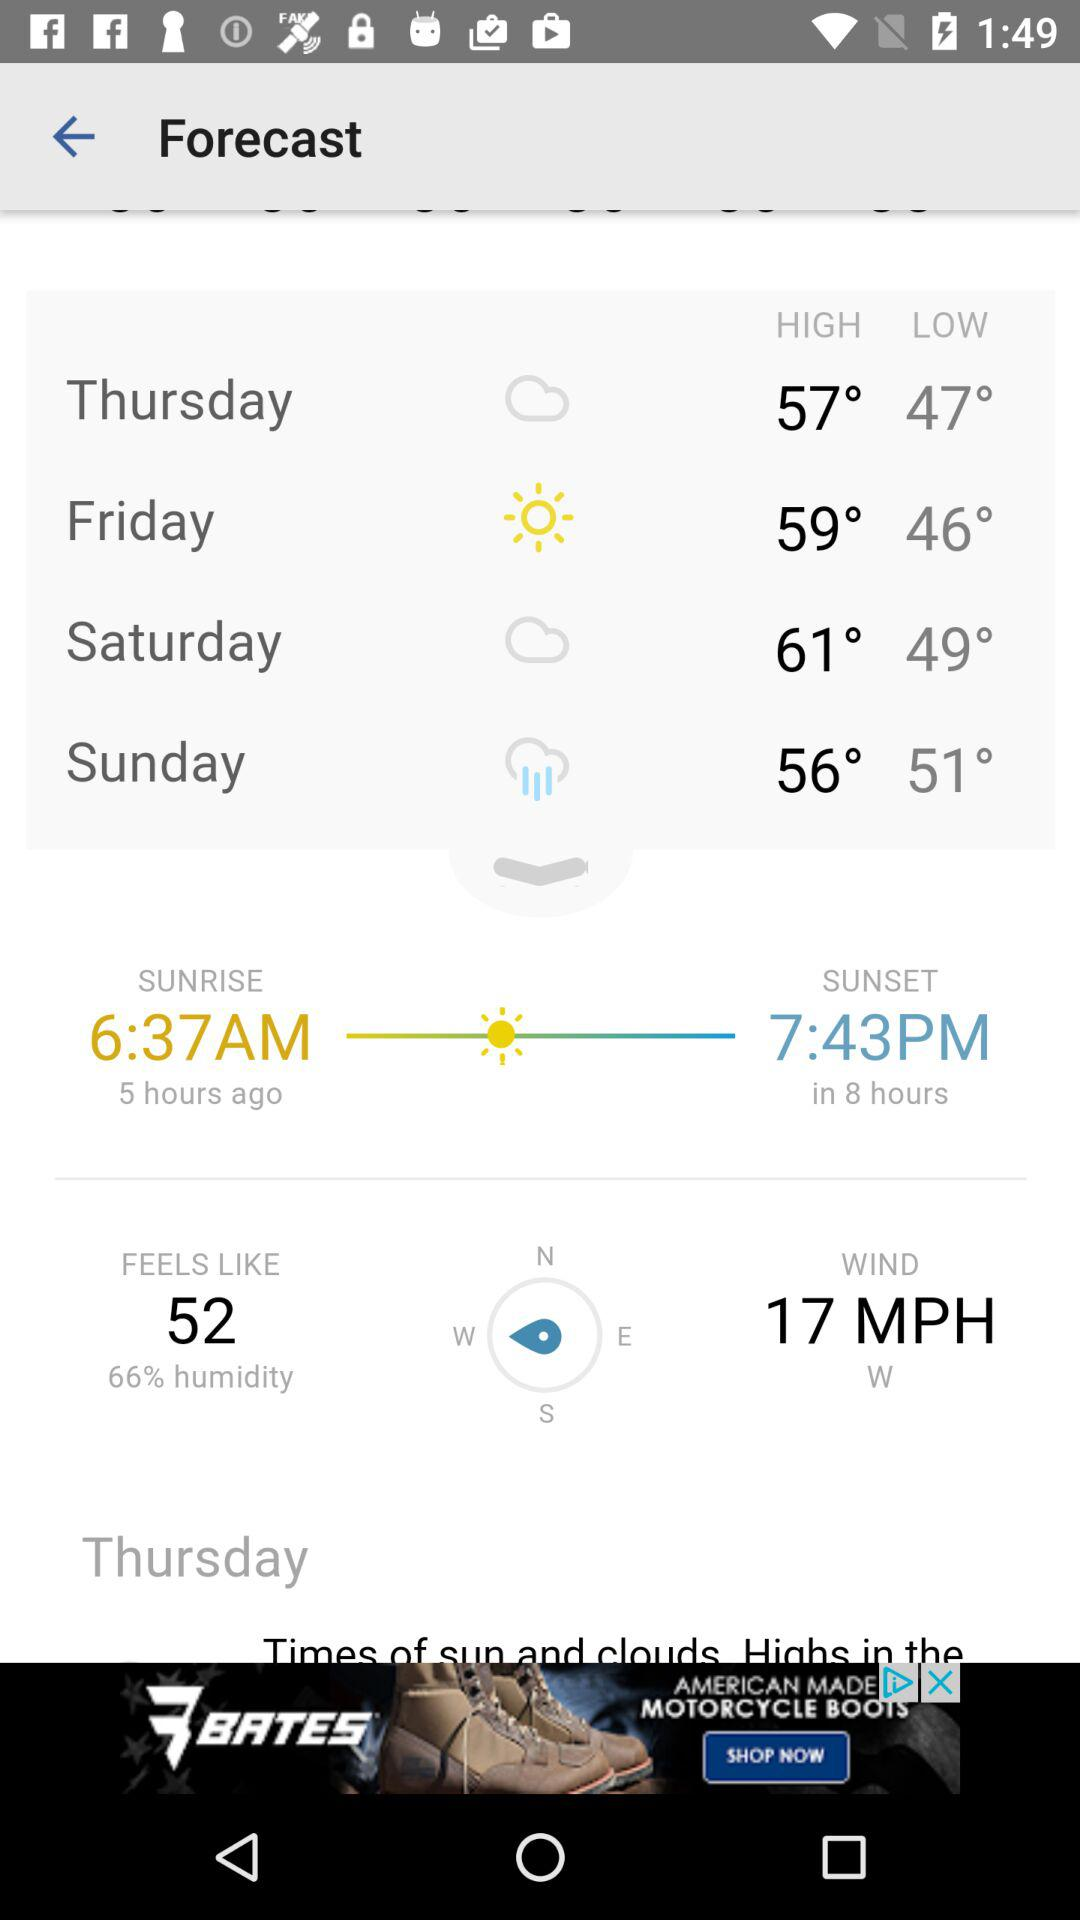What is the time of sunset? The time is 7:43 p.m. 